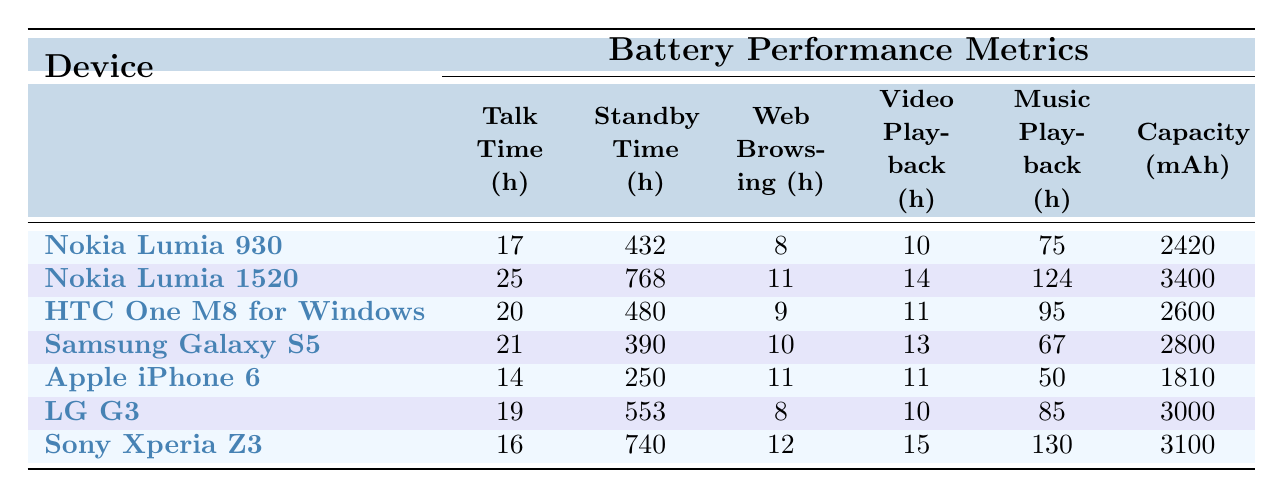What is the talk time of Nokia Lumia 1520? The table shows that the talk time for Nokia Lumia 1520 is 25 hours.
Answer: 25 hours Which device has the longest standby time? According to the table, Nokia Lumia 1520 has the longest standby time of 768 hours.
Answer: Nokia Lumia 1520 What is the music playback time of Samsung Galaxy S5? The table indicates that the music playback time for Samsung Galaxy S5 is 67 hours.
Answer: 67 hours How much longer is the talk time of Nokia Lumia 1520 compared to HTC One M8 for Windows? The talk time of Nokia Lumia 1520 is 25 hours, and HTC One M8 for Windows has 20 hours. The difference is 25 - 20 = 5 hours.
Answer: 5 hours What is the average web browsing time of the listed devices? The web browsing times are 8, 11, 9, 10, 11, 8, and 12 hours. Adding these gives 69 hours. Dividing by 7 devices results in an average of 69 / 7 = 9.857 hours.
Answer: Approximately 9.86 hours Which device has the highest music playback time? By examining the table, Sony Xperia Z3 has the highest music playback time of 130 hours.
Answer: Sony Xperia Z3 Is the standby time of Apple iPhone 6 greater than the music playback time of LG G3? The standby time of Apple iPhone 6 is 250 hours and the music playback time of LG G3 is 85 hours. Since 250 is greater than 85, the answer is yes.
Answer: Yes If we consider the battery capacities, what is the total capacity of all Windows Phone 8.1 devices? The battery capacities for Windows Phone devices are 2420, 3400, and 2600 mAh. Summing these gives 2420 + 3400 + 2600 = 8420 mAh.
Answer: 8420 mAh What is the difference in video playback time between Nokia Lumia 1520 and Samsung Galaxy S5? Nokia Lumia 1520 has a video playback time of 14 hours and Samsung Galaxy S5 has 13 hours. The difference is 14 - 13 = 1 hour.
Answer: 1 hour Who has better web browsing time, HTC One M8 for Windows or Apple iPhone 6? HTC One M8 for Windows has 9 hours, while Apple iPhone 6 has 11 hours. Since 11 is greater than 9, Apple iPhone 6 has better web browsing time.
Answer: Apple iPhone 6 